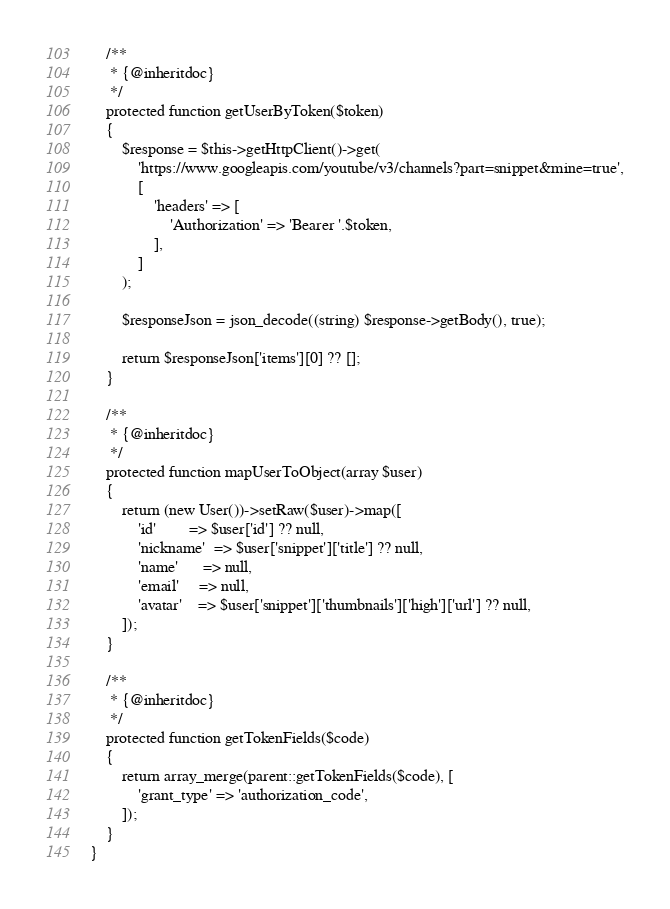<code> <loc_0><loc_0><loc_500><loc_500><_PHP_>    /**
     * {@inheritdoc}
     */
    protected function getUserByToken($token)
    {
        $response = $this->getHttpClient()->get(
            'https://www.googleapis.com/youtube/v3/channels?part=snippet&mine=true',
            [
                'headers' => [
                    'Authorization' => 'Bearer '.$token,
                ],
            ]
        );

        $responseJson = json_decode((string) $response->getBody(), true);

        return $responseJson['items'][0] ?? [];
    }

    /**
     * {@inheritdoc}
     */
    protected function mapUserToObject(array $user)
    {
        return (new User())->setRaw($user)->map([
            'id'        => $user['id'] ?? null,
            'nickname'  => $user['snippet']['title'] ?? null,
            'name'      => null,
            'email'     => null,
            'avatar'    => $user['snippet']['thumbnails']['high']['url'] ?? null,
        ]);
    }

    /**
     * {@inheritdoc}
     */
    protected function getTokenFields($code)
    {
        return array_merge(parent::getTokenFields($code), [
            'grant_type' => 'authorization_code',
        ]);
    }
}
</code> 